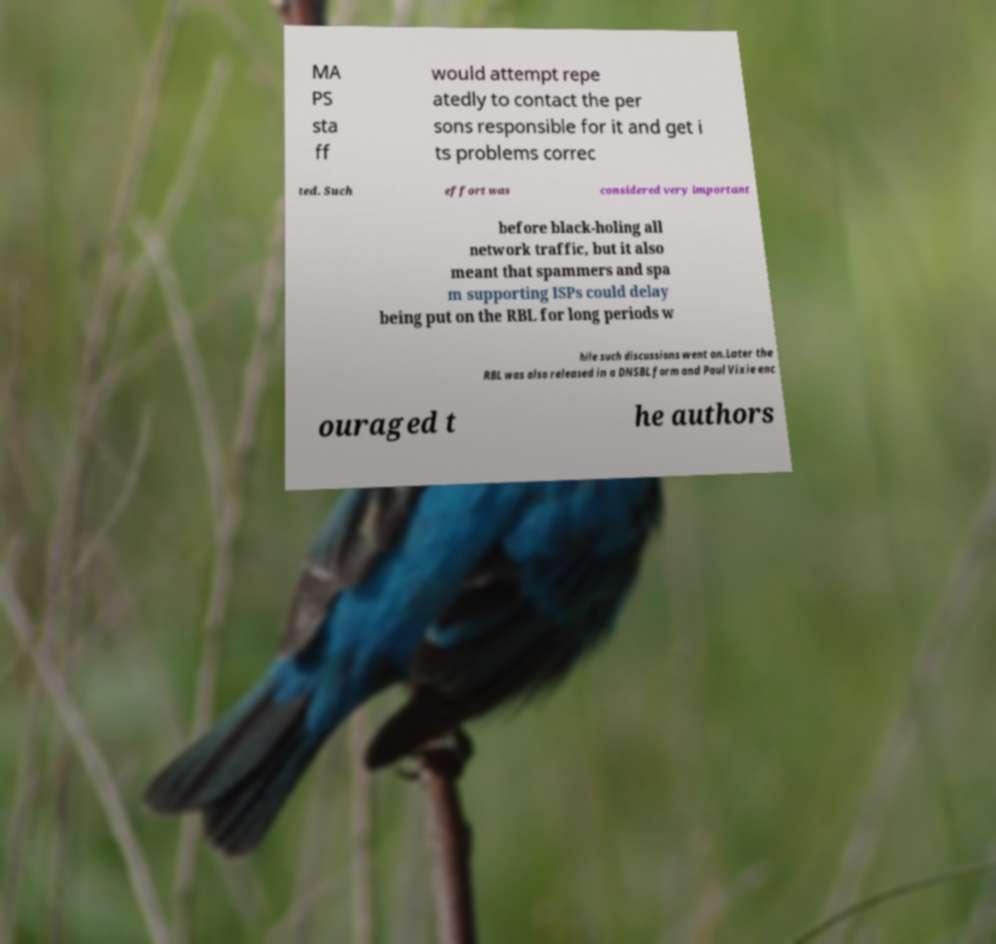There's text embedded in this image that I need extracted. Can you transcribe it verbatim? MA PS sta ff would attempt repe atedly to contact the per sons responsible for it and get i ts problems correc ted. Such effort was considered very important before black-holing all network traffic, but it also meant that spammers and spa m supporting ISPs could delay being put on the RBL for long periods w hile such discussions went on.Later the RBL was also released in a DNSBL form and Paul Vixie enc ouraged t he authors 